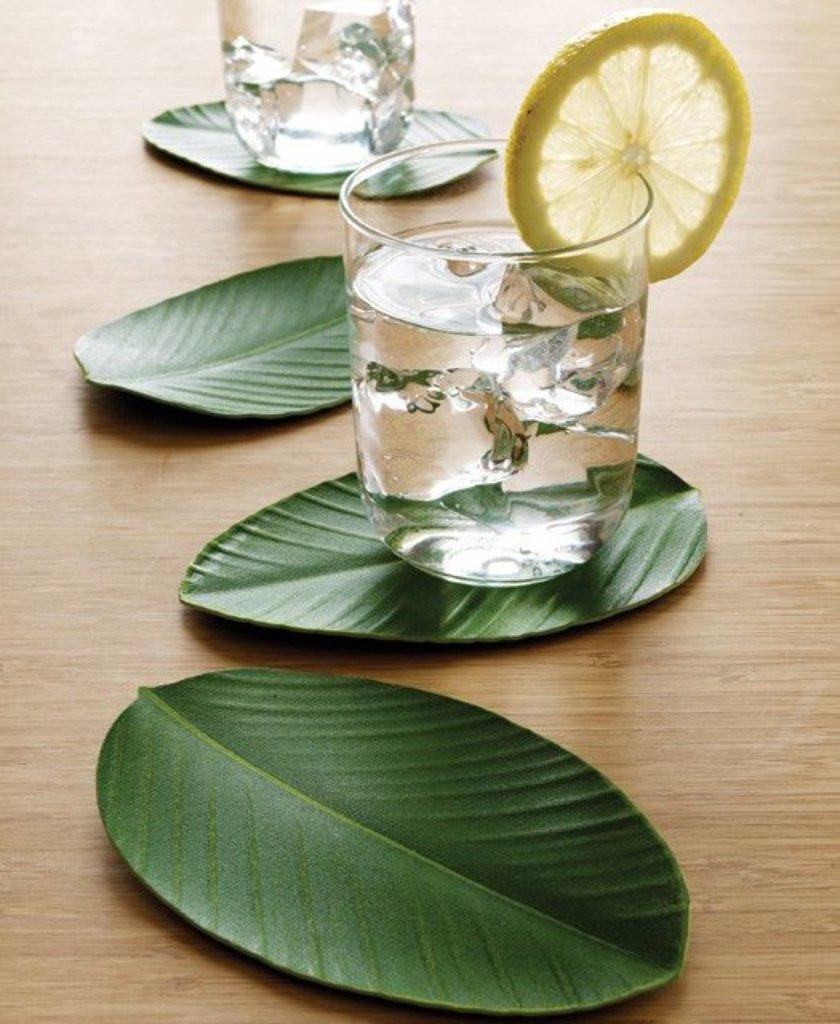What is in the glass that is visible in the image? There is a glass filled with water in the image. What is added to the water in the glass? There is a lemon slice in the glass. What is at the bottom of the glass? There are leaves at the bottom of the glass. How many goldfish are swimming in the glass in the image? There are no goldfish present in the image; it only contains water, a lemon slice, and leaves. 